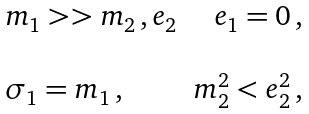<formula> <loc_0><loc_0><loc_500><loc_500>\begin{array} { l r } m _ { 1 } > > m _ { 2 } \, , e _ { 2 } & e _ { 1 } = 0 \, , \\ \\ \sigma _ { 1 } = m _ { 1 } \, , & m _ { 2 } ^ { 2 } < e _ { 2 } ^ { 2 } \, , \end{array}</formula> 